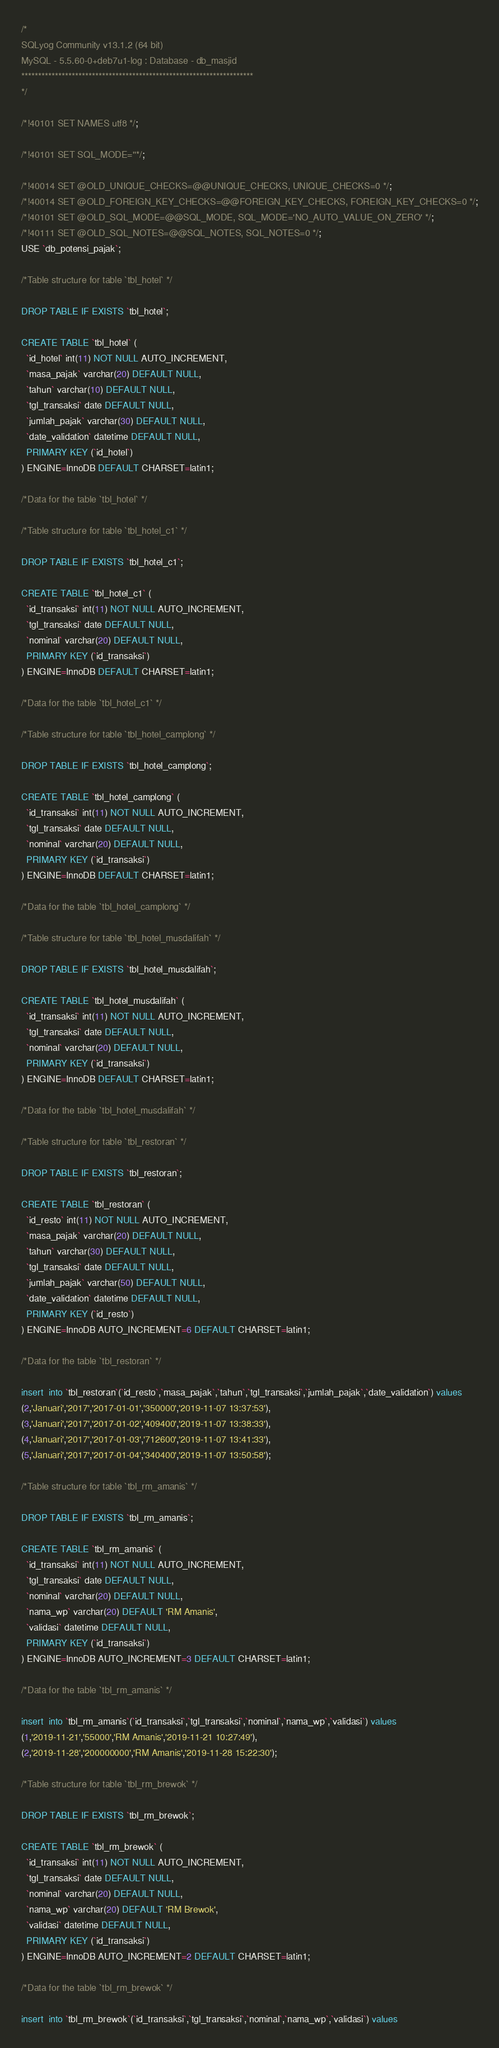Convert code to text. <code><loc_0><loc_0><loc_500><loc_500><_SQL_>/*
SQLyog Community v13.1.2 (64 bit)
MySQL - 5.5.60-0+deb7u1-log : Database - db_masjid
*********************************************************************
*/

/*!40101 SET NAMES utf8 */;

/*!40101 SET SQL_MODE=''*/;

/*!40014 SET @OLD_UNIQUE_CHECKS=@@UNIQUE_CHECKS, UNIQUE_CHECKS=0 */;
/*!40014 SET @OLD_FOREIGN_KEY_CHECKS=@@FOREIGN_KEY_CHECKS, FOREIGN_KEY_CHECKS=0 */;
/*!40101 SET @OLD_SQL_MODE=@@SQL_MODE, SQL_MODE='NO_AUTO_VALUE_ON_ZERO' */;
/*!40111 SET @OLD_SQL_NOTES=@@SQL_NOTES, SQL_NOTES=0 */;
USE `db_potensi_pajak`;

/*Table structure for table `tbl_hotel` */

DROP TABLE IF EXISTS `tbl_hotel`;

CREATE TABLE `tbl_hotel` (
  `id_hotel` int(11) NOT NULL AUTO_INCREMENT,
  `masa_pajak` varchar(20) DEFAULT NULL,
  `tahun` varchar(10) DEFAULT NULL,
  `tgl_transaksi` date DEFAULT NULL,
  `jumlah_pajak` varchar(30) DEFAULT NULL,
  `date_validation` datetime DEFAULT NULL,
  PRIMARY KEY (`id_hotel`)
) ENGINE=InnoDB DEFAULT CHARSET=latin1;

/*Data for the table `tbl_hotel` */

/*Table structure for table `tbl_hotel_c1` */

DROP TABLE IF EXISTS `tbl_hotel_c1`;

CREATE TABLE `tbl_hotel_c1` (
  `id_transaksi` int(11) NOT NULL AUTO_INCREMENT,
  `tgl_transaksi` date DEFAULT NULL,
  `nominal` varchar(20) DEFAULT NULL,
  PRIMARY KEY (`id_transaksi`)
) ENGINE=InnoDB DEFAULT CHARSET=latin1;

/*Data for the table `tbl_hotel_c1` */

/*Table structure for table `tbl_hotel_camplong` */

DROP TABLE IF EXISTS `tbl_hotel_camplong`;

CREATE TABLE `tbl_hotel_camplong` (
  `id_transaksi` int(11) NOT NULL AUTO_INCREMENT,
  `tgl_transaksi` date DEFAULT NULL,
  `nominal` varchar(20) DEFAULT NULL,
  PRIMARY KEY (`id_transaksi`)
) ENGINE=InnoDB DEFAULT CHARSET=latin1;

/*Data for the table `tbl_hotel_camplong` */

/*Table structure for table `tbl_hotel_musdalifah` */

DROP TABLE IF EXISTS `tbl_hotel_musdalifah`;

CREATE TABLE `tbl_hotel_musdalifah` (
  `id_transaksi` int(11) NOT NULL AUTO_INCREMENT,
  `tgl_transaksi` date DEFAULT NULL,
  `nominal` varchar(20) DEFAULT NULL,
  PRIMARY KEY (`id_transaksi`)
) ENGINE=InnoDB DEFAULT CHARSET=latin1;

/*Data for the table `tbl_hotel_musdalifah` */

/*Table structure for table `tbl_restoran` */

DROP TABLE IF EXISTS `tbl_restoran`;

CREATE TABLE `tbl_restoran` (
  `id_resto` int(11) NOT NULL AUTO_INCREMENT,
  `masa_pajak` varchar(20) DEFAULT NULL,
  `tahun` varchar(30) DEFAULT NULL,
  `tgl_transaksi` date DEFAULT NULL,
  `jumlah_pajak` varchar(50) DEFAULT NULL,
  `date_validation` datetime DEFAULT NULL,
  PRIMARY KEY (`id_resto`)
) ENGINE=InnoDB AUTO_INCREMENT=6 DEFAULT CHARSET=latin1;

/*Data for the table `tbl_restoran` */

insert  into `tbl_restoran`(`id_resto`,`masa_pajak`,`tahun`,`tgl_transaksi`,`jumlah_pajak`,`date_validation`) values 
(2,'Januari','2017','2017-01-01','350000','2019-11-07 13:37:53'),
(3,'Januari','2017','2017-01-02','409400','2019-11-07 13:38:33'),
(4,'Januari','2017','2017-01-03','712600','2019-11-07 13:41:33'),
(5,'Januari','2017','2017-01-04','340400','2019-11-07 13:50:58');

/*Table structure for table `tbl_rm_amanis` */

DROP TABLE IF EXISTS `tbl_rm_amanis`;

CREATE TABLE `tbl_rm_amanis` (
  `id_transaksi` int(11) NOT NULL AUTO_INCREMENT,
  `tgl_transaksi` date DEFAULT NULL,
  `nominal` varchar(20) DEFAULT NULL,
  `nama_wp` varchar(20) DEFAULT 'RM Amanis',
  `validasi` datetime DEFAULT NULL,
  PRIMARY KEY (`id_transaksi`)
) ENGINE=InnoDB AUTO_INCREMENT=3 DEFAULT CHARSET=latin1;

/*Data for the table `tbl_rm_amanis` */

insert  into `tbl_rm_amanis`(`id_transaksi`,`tgl_transaksi`,`nominal`,`nama_wp`,`validasi`) values 
(1,'2019-11-21','55000','RM Amanis','2019-11-21 10:27:49'),
(2,'2019-11-28','200000000','RM Amanis','2019-11-28 15:22:30');

/*Table structure for table `tbl_rm_brewok` */

DROP TABLE IF EXISTS `tbl_rm_brewok`;

CREATE TABLE `tbl_rm_brewok` (
  `id_transaksi` int(11) NOT NULL AUTO_INCREMENT,
  `tgl_transaksi` date DEFAULT NULL,
  `nominal` varchar(20) DEFAULT NULL,
  `nama_wp` varchar(20) DEFAULT 'RM Brewok',
  `validasi` datetime DEFAULT NULL,
  PRIMARY KEY (`id_transaksi`)
) ENGINE=InnoDB AUTO_INCREMENT=2 DEFAULT CHARSET=latin1;

/*Data for the table `tbl_rm_brewok` */

insert  into `tbl_rm_brewok`(`id_transaksi`,`tgl_transaksi`,`nominal`,`nama_wp`,`validasi`) values </code> 